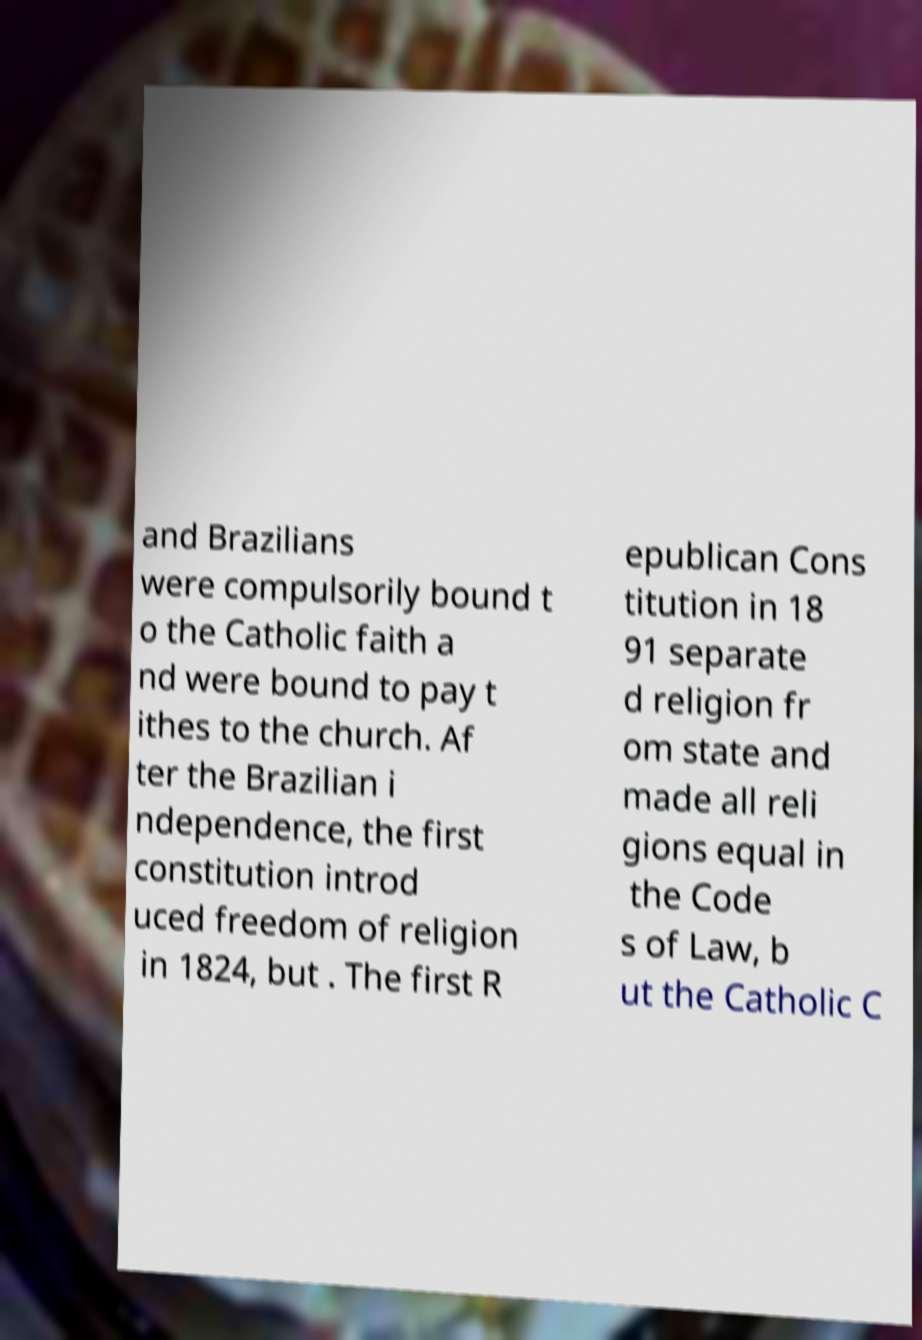For documentation purposes, I need the text within this image transcribed. Could you provide that? and Brazilians were compulsorily bound t o the Catholic faith a nd were bound to pay t ithes to the church. Af ter the Brazilian i ndependence, the first constitution introd uced freedom of religion in 1824, but . The first R epublican Cons titution in 18 91 separate d religion fr om state and made all reli gions equal in the Code s of Law, b ut the Catholic C 